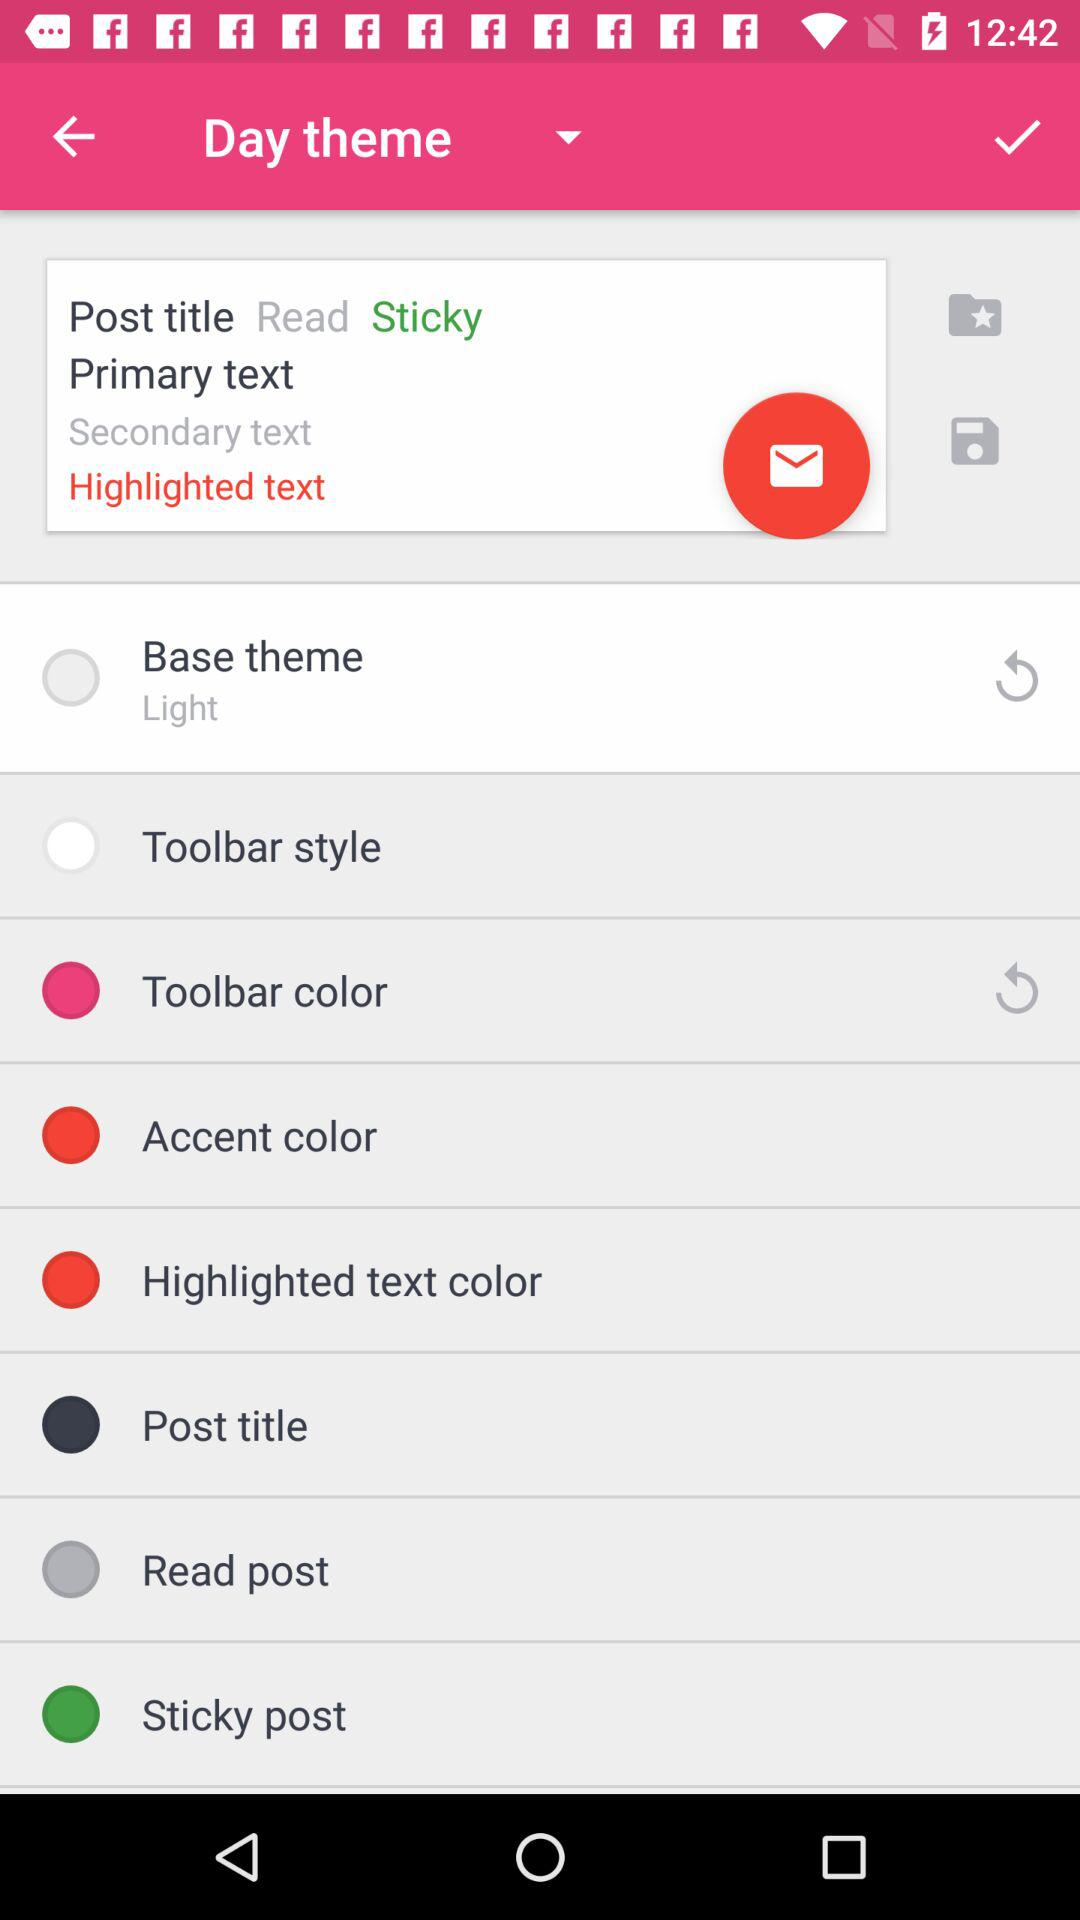Is "Night theme" an option?
When the provided information is insufficient, respond with <no answer>. <no answer> 